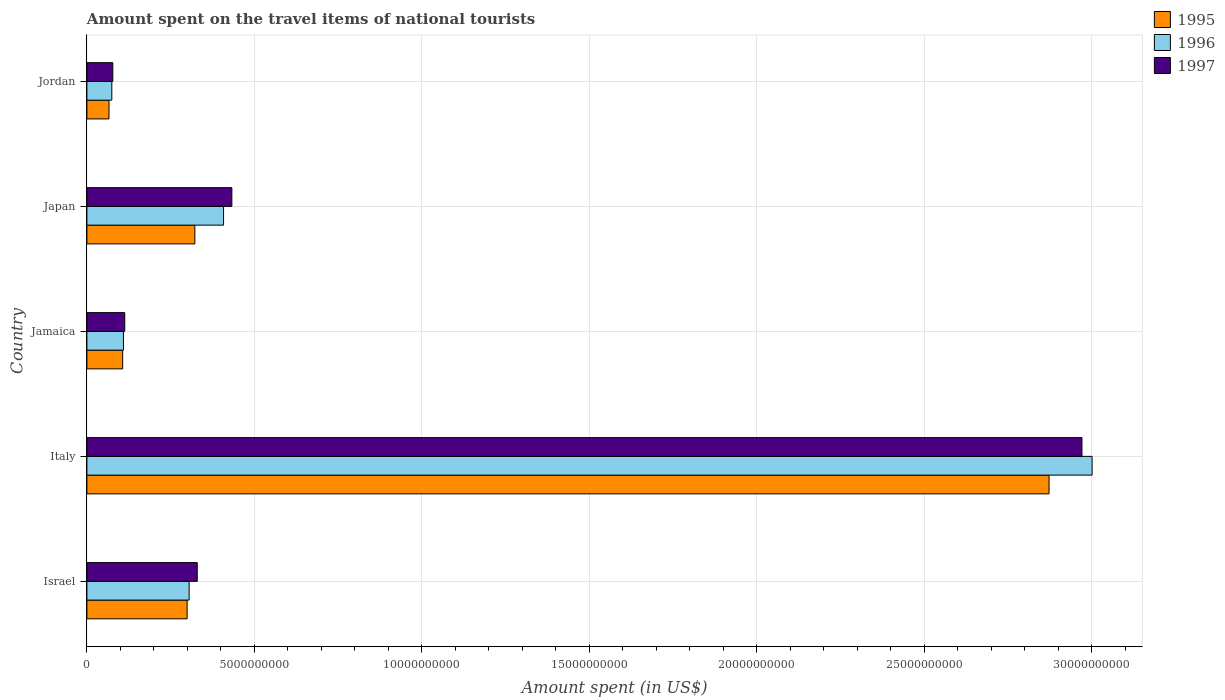How many different coloured bars are there?
Your answer should be very brief. 3. Are the number of bars on each tick of the Y-axis equal?
Provide a short and direct response. Yes. How many bars are there on the 2nd tick from the top?
Offer a terse response. 3. What is the label of the 3rd group of bars from the top?
Keep it short and to the point. Jamaica. In how many cases, is the number of bars for a given country not equal to the number of legend labels?
Keep it short and to the point. 0. What is the amount spent on the travel items of national tourists in 1996 in Israel?
Your answer should be very brief. 3.05e+09. Across all countries, what is the maximum amount spent on the travel items of national tourists in 1995?
Provide a succinct answer. 2.87e+1. Across all countries, what is the minimum amount spent on the travel items of national tourists in 1997?
Ensure brevity in your answer.  7.74e+08. In which country was the amount spent on the travel items of national tourists in 1995 maximum?
Make the answer very short. Italy. In which country was the amount spent on the travel items of national tourists in 1997 minimum?
Provide a short and direct response. Jordan. What is the total amount spent on the travel items of national tourists in 1996 in the graph?
Provide a short and direct response. 3.90e+1. What is the difference between the amount spent on the travel items of national tourists in 1996 in Jamaica and that in Japan?
Make the answer very short. -2.99e+09. What is the difference between the amount spent on the travel items of national tourists in 1996 in Israel and the amount spent on the travel items of national tourists in 1995 in Jamaica?
Offer a terse response. 1.98e+09. What is the average amount spent on the travel items of national tourists in 1997 per country?
Your answer should be very brief. 7.85e+09. What is the difference between the amount spent on the travel items of national tourists in 1996 and amount spent on the travel items of national tourists in 1995 in Italy?
Provide a short and direct response. 1.29e+09. In how many countries, is the amount spent on the travel items of national tourists in 1997 greater than 29000000000 US$?
Make the answer very short. 1. What is the ratio of the amount spent on the travel items of national tourists in 1995 in Israel to that in Jordan?
Ensure brevity in your answer.  4.53. Is the amount spent on the travel items of national tourists in 1996 in Jamaica less than that in Jordan?
Provide a succinct answer. No. What is the difference between the highest and the second highest amount spent on the travel items of national tourists in 1995?
Your answer should be very brief. 2.55e+1. What is the difference between the highest and the lowest amount spent on the travel items of national tourists in 1996?
Make the answer very short. 2.93e+1. In how many countries, is the amount spent on the travel items of national tourists in 1996 greater than the average amount spent on the travel items of national tourists in 1996 taken over all countries?
Provide a short and direct response. 1. Are all the bars in the graph horizontal?
Offer a very short reply. Yes. How many countries are there in the graph?
Give a very brief answer. 5. Are the values on the major ticks of X-axis written in scientific E-notation?
Provide a succinct answer. No. How are the legend labels stacked?
Give a very brief answer. Vertical. What is the title of the graph?
Your response must be concise. Amount spent on the travel items of national tourists. What is the label or title of the X-axis?
Give a very brief answer. Amount spent (in US$). What is the label or title of the Y-axis?
Offer a terse response. Country. What is the Amount spent (in US$) in 1995 in Israel?
Offer a terse response. 2.99e+09. What is the Amount spent (in US$) of 1996 in Israel?
Offer a very short reply. 3.05e+09. What is the Amount spent (in US$) in 1997 in Israel?
Keep it short and to the point. 3.30e+09. What is the Amount spent (in US$) of 1995 in Italy?
Ensure brevity in your answer.  2.87e+1. What is the Amount spent (in US$) in 1996 in Italy?
Offer a very short reply. 3.00e+1. What is the Amount spent (in US$) of 1997 in Italy?
Offer a very short reply. 2.97e+1. What is the Amount spent (in US$) in 1995 in Jamaica?
Keep it short and to the point. 1.07e+09. What is the Amount spent (in US$) in 1996 in Jamaica?
Offer a very short reply. 1.09e+09. What is the Amount spent (in US$) in 1997 in Jamaica?
Keep it short and to the point. 1.13e+09. What is the Amount spent (in US$) of 1995 in Japan?
Offer a terse response. 3.22e+09. What is the Amount spent (in US$) in 1996 in Japan?
Provide a short and direct response. 4.08e+09. What is the Amount spent (in US$) of 1997 in Japan?
Keep it short and to the point. 4.33e+09. What is the Amount spent (in US$) in 1995 in Jordan?
Your answer should be very brief. 6.60e+08. What is the Amount spent (in US$) in 1996 in Jordan?
Ensure brevity in your answer.  7.44e+08. What is the Amount spent (in US$) of 1997 in Jordan?
Make the answer very short. 7.74e+08. Across all countries, what is the maximum Amount spent (in US$) of 1995?
Keep it short and to the point. 2.87e+1. Across all countries, what is the maximum Amount spent (in US$) of 1996?
Offer a very short reply. 3.00e+1. Across all countries, what is the maximum Amount spent (in US$) of 1997?
Keep it short and to the point. 2.97e+1. Across all countries, what is the minimum Amount spent (in US$) of 1995?
Ensure brevity in your answer.  6.60e+08. Across all countries, what is the minimum Amount spent (in US$) in 1996?
Your answer should be very brief. 7.44e+08. Across all countries, what is the minimum Amount spent (in US$) of 1997?
Make the answer very short. 7.74e+08. What is the total Amount spent (in US$) of 1995 in the graph?
Keep it short and to the point. 3.67e+1. What is the total Amount spent (in US$) of 1996 in the graph?
Your response must be concise. 3.90e+1. What is the total Amount spent (in US$) in 1997 in the graph?
Offer a terse response. 3.92e+1. What is the difference between the Amount spent (in US$) of 1995 in Israel and that in Italy?
Offer a terse response. -2.57e+1. What is the difference between the Amount spent (in US$) of 1996 in Israel and that in Italy?
Keep it short and to the point. -2.70e+1. What is the difference between the Amount spent (in US$) of 1997 in Israel and that in Italy?
Your response must be concise. -2.64e+1. What is the difference between the Amount spent (in US$) of 1995 in Israel and that in Jamaica?
Make the answer very short. 1.92e+09. What is the difference between the Amount spent (in US$) in 1996 in Israel and that in Jamaica?
Provide a succinct answer. 1.96e+09. What is the difference between the Amount spent (in US$) in 1997 in Israel and that in Jamaica?
Keep it short and to the point. 2.16e+09. What is the difference between the Amount spent (in US$) of 1995 in Israel and that in Japan?
Your answer should be very brief. -2.31e+08. What is the difference between the Amount spent (in US$) in 1996 in Israel and that in Japan?
Keep it short and to the point. -1.03e+09. What is the difference between the Amount spent (in US$) of 1997 in Israel and that in Japan?
Keep it short and to the point. -1.03e+09. What is the difference between the Amount spent (in US$) of 1995 in Israel and that in Jordan?
Make the answer very short. 2.33e+09. What is the difference between the Amount spent (in US$) in 1996 in Israel and that in Jordan?
Keep it short and to the point. 2.31e+09. What is the difference between the Amount spent (in US$) in 1997 in Israel and that in Jordan?
Offer a very short reply. 2.52e+09. What is the difference between the Amount spent (in US$) of 1995 in Italy and that in Jamaica?
Keep it short and to the point. 2.77e+1. What is the difference between the Amount spent (in US$) of 1996 in Italy and that in Jamaica?
Make the answer very short. 2.89e+1. What is the difference between the Amount spent (in US$) in 1997 in Italy and that in Jamaica?
Offer a very short reply. 2.86e+1. What is the difference between the Amount spent (in US$) of 1995 in Italy and that in Japan?
Your answer should be very brief. 2.55e+1. What is the difference between the Amount spent (in US$) in 1996 in Italy and that in Japan?
Ensure brevity in your answer.  2.59e+1. What is the difference between the Amount spent (in US$) in 1997 in Italy and that in Japan?
Give a very brief answer. 2.54e+1. What is the difference between the Amount spent (in US$) of 1995 in Italy and that in Jordan?
Give a very brief answer. 2.81e+1. What is the difference between the Amount spent (in US$) of 1996 in Italy and that in Jordan?
Your response must be concise. 2.93e+1. What is the difference between the Amount spent (in US$) of 1997 in Italy and that in Jordan?
Your answer should be compact. 2.89e+1. What is the difference between the Amount spent (in US$) in 1995 in Jamaica and that in Japan?
Keep it short and to the point. -2.16e+09. What is the difference between the Amount spent (in US$) of 1996 in Jamaica and that in Japan?
Offer a terse response. -2.99e+09. What is the difference between the Amount spent (in US$) in 1997 in Jamaica and that in Japan?
Offer a very short reply. -3.20e+09. What is the difference between the Amount spent (in US$) in 1995 in Jamaica and that in Jordan?
Your answer should be very brief. 4.09e+08. What is the difference between the Amount spent (in US$) in 1996 in Jamaica and that in Jordan?
Keep it short and to the point. 3.48e+08. What is the difference between the Amount spent (in US$) of 1997 in Jamaica and that in Jordan?
Your answer should be compact. 3.57e+08. What is the difference between the Amount spent (in US$) of 1995 in Japan and that in Jordan?
Keep it short and to the point. 2.56e+09. What is the difference between the Amount spent (in US$) of 1996 in Japan and that in Jordan?
Ensure brevity in your answer.  3.34e+09. What is the difference between the Amount spent (in US$) in 1997 in Japan and that in Jordan?
Make the answer very short. 3.56e+09. What is the difference between the Amount spent (in US$) in 1995 in Israel and the Amount spent (in US$) in 1996 in Italy?
Offer a very short reply. -2.70e+1. What is the difference between the Amount spent (in US$) of 1995 in Israel and the Amount spent (in US$) of 1997 in Italy?
Provide a short and direct response. -2.67e+1. What is the difference between the Amount spent (in US$) in 1996 in Israel and the Amount spent (in US$) in 1997 in Italy?
Make the answer very short. -2.67e+1. What is the difference between the Amount spent (in US$) in 1995 in Israel and the Amount spent (in US$) in 1996 in Jamaica?
Your answer should be very brief. 1.90e+09. What is the difference between the Amount spent (in US$) in 1995 in Israel and the Amount spent (in US$) in 1997 in Jamaica?
Your answer should be very brief. 1.86e+09. What is the difference between the Amount spent (in US$) in 1996 in Israel and the Amount spent (in US$) in 1997 in Jamaica?
Provide a short and direct response. 1.92e+09. What is the difference between the Amount spent (in US$) in 1995 in Israel and the Amount spent (in US$) in 1996 in Japan?
Ensure brevity in your answer.  -1.09e+09. What is the difference between the Amount spent (in US$) in 1995 in Israel and the Amount spent (in US$) in 1997 in Japan?
Provide a succinct answer. -1.34e+09. What is the difference between the Amount spent (in US$) in 1996 in Israel and the Amount spent (in US$) in 1997 in Japan?
Keep it short and to the point. -1.28e+09. What is the difference between the Amount spent (in US$) in 1995 in Israel and the Amount spent (in US$) in 1996 in Jordan?
Provide a succinct answer. 2.25e+09. What is the difference between the Amount spent (in US$) in 1995 in Israel and the Amount spent (in US$) in 1997 in Jordan?
Give a very brief answer. 2.22e+09. What is the difference between the Amount spent (in US$) in 1996 in Israel and the Amount spent (in US$) in 1997 in Jordan?
Make the answer very short. 2.28e+09. What is the difference between the Amount spent (in US$) of 1995 in Italy and the Amount spent (in US$) of 1996 in Jamaica?
Give a very brief answer. 2.76e+1. What is the difference between the Amount spent (in US$) of 1995 in Italy and the Amount spent (in US$) of 1997 in Jamaica?
Provide a succinct answer. 2.76e+1. What is the difference between the Amount spent (in US$) of 1996 in Italy and the Amount spent (in US$) of 1997 in Jamaica?
Your response must be concise. 2.89e+1. What is the difference between the Amount spent (in US$) of 1995 in Italy and the Amount spent (in US$) of 1996 in Japan?
Provide a succinct answer. 2.46e+1. What is the difference between the Amount spent (in US$) in 1995 in Italy and the Amount spent (in US$) in 1997 in Japan?
Your response must be concise. 2.44e+1. What is the difference between the Amount spent (in US$) of 1996 in Italy and the Amount spent (in US$) of 1997 in Japan?
Offer a terse response. 2.57e+1. What is the difference between the Amount spent (in US$) of 1995 in Italy and the Amount spent (in US$) of 1996 in Jordan?
Your answer should be very brief. 2.80e+1. What is the difference between the Amount spent (in US$) in 1995 in Italy and the Amount spent (in US$) in 1997 in Jordan?
Offer a terse response. 2.80e+1. What is the difference between the Amount spent (in US$) of 1996 in Italy and the Amount spent (in US$) of 1997 in Jordan?
Keep it short and to the point. 2.92e+1. What is the difference between the Amount spent (in US$) of 1995 in Jamaica and the Amount spent (in US$) of 1996 in Japan?
Ensure brevity in your answer.  -3.01e+09. What is the difference between the Amount spent (in US$) in 1995 in Jamaica and the Amount spent (in US$) in 1997 in Japan?
Ensure brevity in your answer.  -3.26e+09. What is the difference between the Amount spent (in US$) in 1996 in Jamaica and the Amount spent (in US$) in 1997 in Japan?
Make the answer very short. -3.24e+09. What is the difference between the Amount spent (in US$) in 1995 in Jamaica and the Amount spent (in US$) in 1996 in Jordan?
Offer a very short reply. 3.25e+08. What is the difference between the Amount spent (in US$) of 1995 in Jamaica and the Amount spent (in US$) of 1997 in Jordan?
Offer a very short reply. 2.95e+08. What is the difference between the Amount spent (in US$) in 1996 in Jamaica and the Amount spent (in US$) in 1997 in Jordan?
Provide a succinct answer. 3.18e+08. What is the difference between the Amount spent (in US$) of 1995 in Japan and the Amount spent (in US$) of 1996 in Jordan?
Your response must be concise. 2.48e+09. What is the difference between the Amount spent (in US$) of 1995 in Japan and the Amount spent (in US$) of 1997 in Jordan?
Give a very brief answer. 2.45e+09. What is the difference between the Amount spent (in US$) of 1996 in Japan and the Amount spent (in US$) of 1997 in Jordan?
Your answer should be very brief. 3.31e+09. What is the average Amount spent (in US$) of 1995 per country?
Your response must be concise. 7.34e+09. What is the average Amount spent (in US$) of 1996 per country?
Give a very brief answer. 7.80e+09. What is the average Amount spent (in US$) of 1997 per country?
Make the answer very short. 7.85e+09. What is the difference between the Amount spent (in US$) of 1995 and Amount spent (in US$) of 1996 in Israel?
Offer a very short reply. -6.00e+07. What is the difference between the Amount spent (in US$) in 1995 and Amount spent (in US$) in 1997 in Israel?
Your answer should be compact. -3.02e+08. What is the difference between the Amount spent (in US$) of 1996 and Amount spent (in US$) of 1997 in Israel?
Your answer should be very brief. -2.42e+08. What is the difference between the Amount spent (in US$) of 1995 and Amount spent (in US$) of 1996 in Italy?
Ensure brevity in your answer.  -1.29e+09. What is the difference between the Amount spent (in US$) of 1995 and Amount spent (in US$) of 1997 in Italy?
Keep it short and to the point. -9.83e+08. What is the difference between the Amount spent (in US$) in 1996 and Amount spent (in US$) in 1997 in Italy?
Provide a short and direct response. 3.03e+08. What is the difference between the Amount spent (in US$) of 1995 and Amount spent (in US$) of 1996 in Jamaica?
Offer a terse response. -2.30e+07. What is the difference between the Amount spent (in US$) in 1995 and Amount spent (in US$) in 1997 in Jamaica?
Provide a succinct answer. -6.20e+07. What is the difference between the Amount spent (in US$) in 1996 and Amount spent (in US$) in 1997 in Jamaica?
Ensure brevity in your answer.  -3.90e+07. What is the difference between the Amount spent (in US$) in 1995 and Amount spent (in US$) in 1996 in Japan?
Your answer should be very brief. -8.57e+08. What is the difference between the Amount spent (in US$) in 1995 and Amount spent (in US$) in 1997 in Japan?
Give a very brief answer. -1.10e+09. What is the difference between the Amount spent (in US$) in 1996 and Amount spent (in US$) in 1997 in Japan?
Your answer should be compact. -2.48e+08. What is the difference between the Amount spent (in US$) in 1995 and Amount spent (in US$) in 1996 in Jordan?
Provide a succinct answer. -8.40e+07. What is the difference between the Amount spent (in US$) of 1995 and Amount spent (in US$) of 1997 in Jordan?
Offer a very short reply. -1.14e+08. What is the difference between the Amount spent (in US$) in 1996 and Amount spent (in US$) in 1997 in Jordan?
Make the answer very short. -3.00e+07. What is the ratio of the Amount spent (in US$) in 1995 in Israel to that in Italy?
Offer a very short reply. 0.1. What is the ratio of the Amount spent (in US$) of 1996 in Israel to that in Italy?
Provide a succinct answer. 0.1. What is the ratio of the Amount spent (in US$) of 1997 in Israel to that in Italy?
Your answer should be very brief. 0.11. What is the ratio of the Amount spent (in US$) in 1995 in Israel to that in Jamaica?
Your answer should be compact. 2.8. What is the ratio of the Amount spent (in US$) in 1996 in Israel to that in Jamaica?
Offer a terse response. 2.8. What is the ratio of the Amount spent (in US$) in 1997 in Israel to that in Jamaica?
Your response must be concise. 2.91. What is the ratio of the Amount spent (in US$) in 1995 in Israel to that in Japan?
Provide a succinct answer. 0.93. What is the ratio of the Amount spent (in US$) in 1996 in Israel to that in Japan?
Ensure brevity in your answer.  0.75. What is the ratio of the Amount spent (in US$) of 1997 in Israel to that in Japan?
Your answer should be compact. 0.76. What is the ratio of the Amount spent (in US$) of 1995 in Israel to that in Jordan?
Offer a terse response. 4.53. What is the ratio of the Amount spent (in US$) of 1996 in Israel to that in Jordan?
Make the answer very short. 4.1. What is the ratio of the Amount spent (in US$) of 1997 in Israel to that in Jordan?
Your response must be concise. 4.26. What is the ratio of the Amount spent (in US$) of 1995 in Italy to that in Jamaica?
Your answer should be compact. 26.88. What is the ratio of the Amount spent (in US$) in 1996 in Italy to that in Jamaica?
Make the answer very short. 27.49. What is the ratio of the Amount spent (in US$) of 1997 in Italy to that in Jamaica?
Ensure brevity in your answer.  26.27. What is the ratio of the Amount spent (in US$) of 1995 in Italy to that in Japan?
Ensure brevity in your answer.  8.91. What is the ratio of the Amount spent (in US$) in 1996 in Italy to that in Japan?
Your answer should be very brief. 7.36. What is the ratio of the Amount spent (in US$) of 1997 in Italy to that in Japan?
Your answer should be very brief. 6.86. What is the ratio of the Amount spent (in US$) of 1995 in Italy to that in Jordan?
Keep it short and to the point. 43.53. What is the ratio of the Amount spent (in US$) of 1996 in Italy to that in Jordan?
Offer a terse response. 40.35. What is the ratio of the Amount spent (in US$) of 1997 in Italy to that in Jordan?
Make the answer very short. 38.39. What is the ratio of the Amount spent (in US$) of 1995 in Jamaica to that in Japan?
Offer a terse response. 0.33. What is the ratio of the Amount spent (in US$) in 1996 in Jamaica to that in Japan?
Your answer should be compact. 0.27. What is the ratio of the Amount spent (in US$) of 1997 in Jamaica to that in Japan?
Provide a short and direct response. 0.26. What is the ratio of the Amount spent (in US$) in 1995 in Jamaica to that in Jordan?
Provide a succinct answer. 1.62. What is the ratio of the Amount spent (in US$) of 1996 in Jamaica to that in Jordan?
Ensure brevity in your answer.  1.47. What is the ratio of the Amount spent (in US$) in 1997 in Jamaica to that in Jordan?
Offer a very short reply. 1.46. What is the ratio of the Amount spent (in US$) in 1995 in Japan to that in Jordan?
Keep it short and to the point. 4.88. What is the ratio of the Amount spent (in US$) in 1996 in Japan to that in Jordan?
Provide a succinct answer. 5.49. What is the ratio of the Amount spent (in US$) in 1997 in Japan to that in Jordan?
Provide a short and direct response. 5.59. What is the difference between the highest and the second highest Amount spent (in US$) in 1995?
Make the answer very short. 2.55e+1. What is the difference between the highest and the second highest Amount spent (in US$) of 1996?
Offer a terse response. 2.59e+1. What is the difference between the highest and the second highest Amount spent (in US$) in 1997?
Provide a short and direct response. 2.54e+1. What is the difference between the highest and the lowest Amount spent (in US$) in 1995?
Make the answer very short. 2.81e+1. What is the difference between the highest and the lowest Amount spent (in US$) of 1996?
Provide a short and direct response. 2.93e+1. What is the difference between the highest and the lowest Amount spent (in US$) of 1997?
Give a very brief answer. 2.89e+1. 